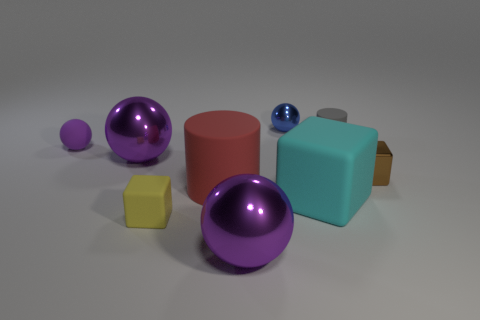Subtract all purple spheres. How many were subtracted if there are1purple spheres left? 2 Subtract all gray cubes. How many purple spheres are left? 3 Add 1 large purple shiny things. How many objects exist? 10 Subtract all cylinders. How many objects are left? 7 Add 1 red matte cubes. How many red matte cubes exist? 1 Subtract 1 blue balls. How many objects are left? 8 Subtract all large purple objects. Subtract all brown cubes. How many objects are left? 6 Add 1 purple metal things. How many purple metal things are left? 3 